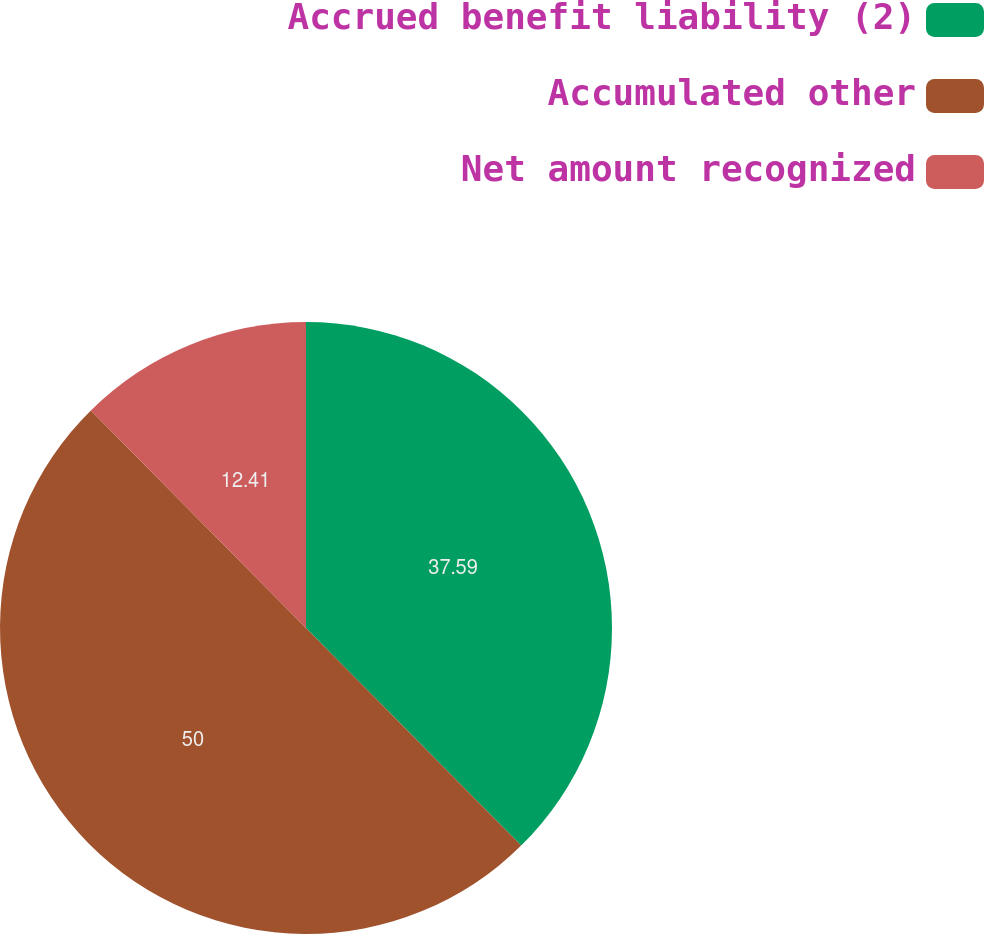Convert chart. <chart><loc_0><loc_0><loc_500><loc_500><pie_chart><fcel>Accrued benefit liability (2)<fcel>Accumulated other<fcel>Net amount recognized<nl><fcel>37.59%<fcel>50.0%<fcel>12.41%<nl></chart> 